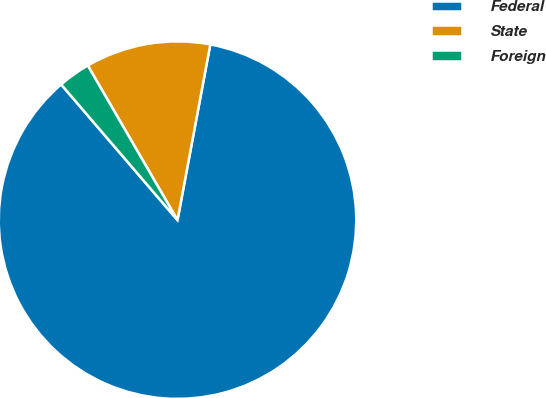Convert chart to OTSL. <chart><loc_0><loc_0><loc_500><loc_500><pie_chart><fcel>Federal<fcel>State<fcel>Foreign<nl><fcel>85.78%<fcel>11.31%<fcel>2.91%<nl></chart> 